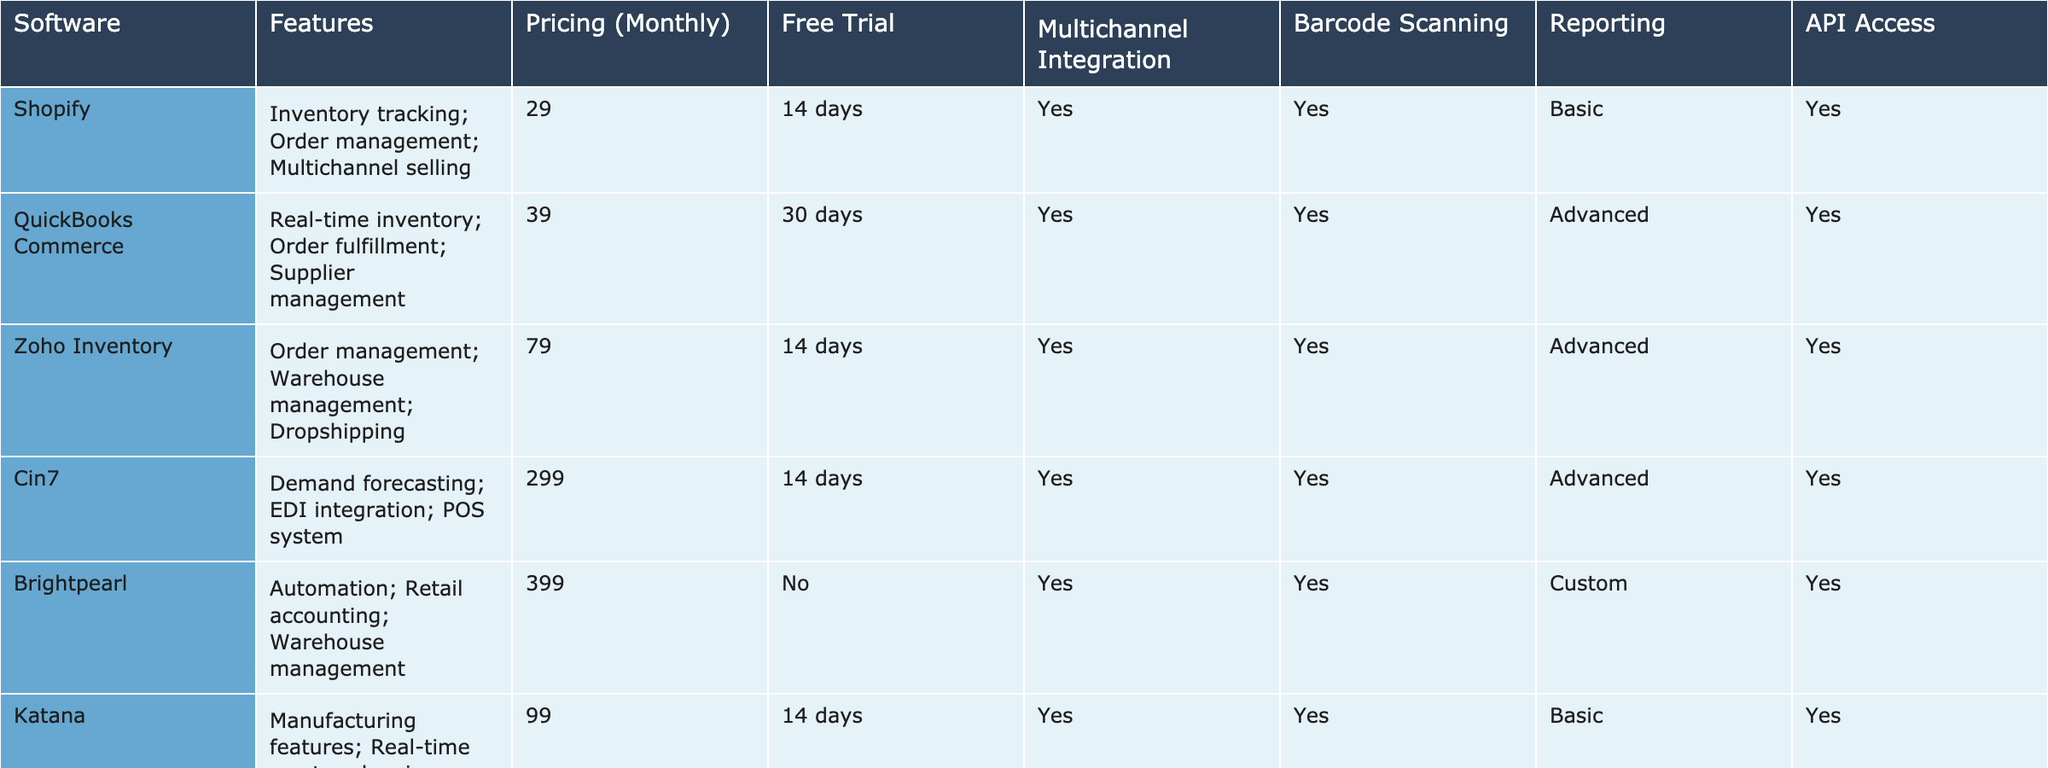What is the monthly pricing of Zoho Inventory? The table lists Zoho Inventory under the Software column with its corresponding Pricing (Monthly) next to it, which is 79.
Answer: 79 Does Sellbrite offer a free trial? Looking at the Free Trial column, Sellbrite is shown to have "Yes" in this section, indicating that it offers a free trial.
Answer: Yes Which software has the highest pricing? By inspecting the Pricing (Monthly) column, Brightpearl has the highest value listed at 399, making it the most expensive software in the table.
Answer: Brightpearl How many software options provide advanced reporting features? The Reporting column indicates which software have advanced reporting capabilities. QuickBooks Commerce, Zoho Inventory, Cin7, Veeqo, Orderhive, and SkuVault have "Advanced", totaling 6 options.
Answer: 6 Which software does not support barcode scanning? In reviewing the Barcode Scanning column, only Sellbrite has "No" listed, meaning it does not support barcode scanning.
Answer: Sellbrite What is the average monthly pricing of the software that offers a free trial? To find the average for software with a free trial, the monthly pricing of those software needs to be summed together: 29, 39, 79, 299, 99, 156, 49, and 44.99, which totals 794. There are 8 software options that offer a free trial, so dividing 794 by 8 gives an average price of 99.25.
Answer: 99.25 Which software provides API access but does not have a free trial? The table shows SkuVault and Brightpearl in the Software column. However, only SkuVault has "Yes" in the API Access column, while Brightpearl has "No" in Free Trial, confirming that SkuVault provides API access without offering a free trial.
Answer: SkuVault How many total software solutions support multichannel integration? By checking the Multichannel Integration column, all software except Brightpearl (which states "No"), support multichannel integration. There are a total of 9 software options in the list, resulting in 8 that have multichannel integration support.
Answer: 8 